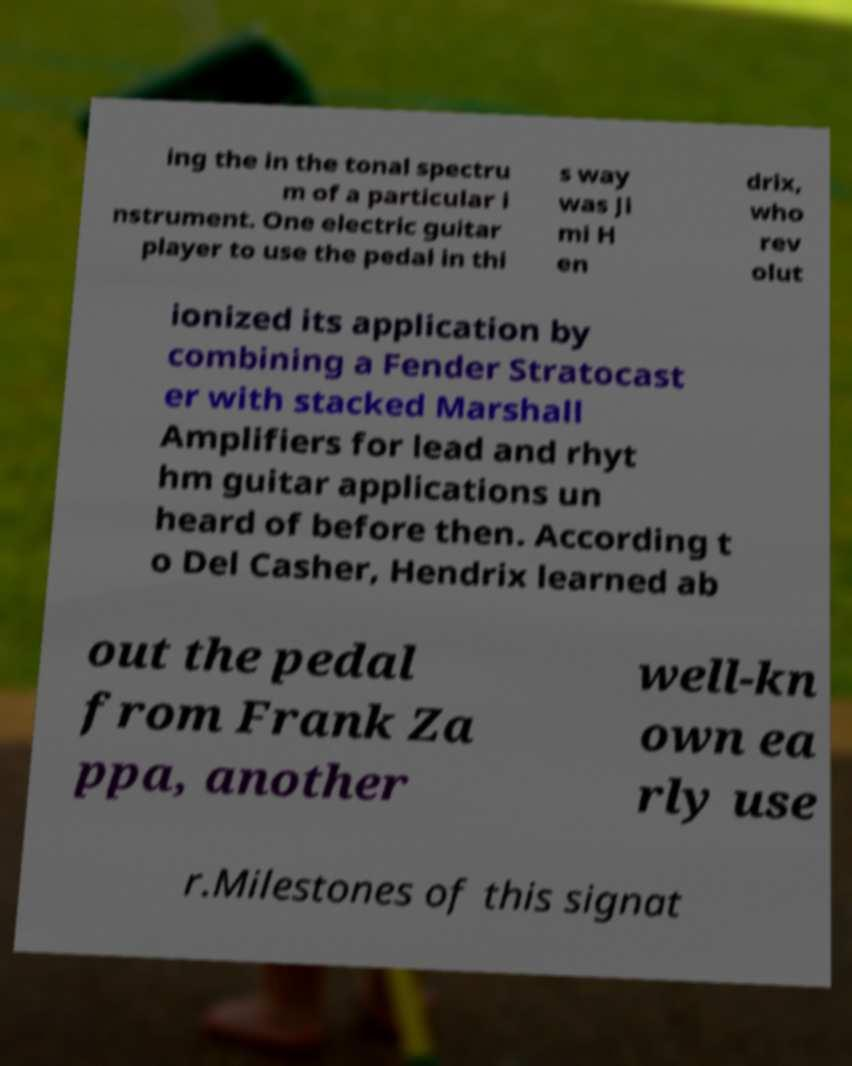Please read and relay the text visible in this image. What does it say? ing the in the tonal spectru m of a particular i nstrument. One electric guitar player to use the pedal in thi s way was Ji mi H en drix, who rev olut ionized its application by combining a Fender Stratocast er with stacked Marshall Amplifiers for lead and rhyt hm guitar applications un heard of before then. According t o Del Casher, Hendrix learned ab out the pedal from Frank Za ppa, another well-kn own ea rly use r.Milestones of this signat 